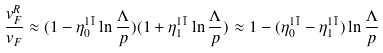<formula> <loc_0><loc_0><loc_500><loc_500>\frac { v _ { F } ^ { R } } { v _ { F } } \approx ( 1 - \eta ^ { 1 \bar { 1 } } _ { 0 } \ln { \frac { \Lambda } { p } } ) ( 1 + \eta ^ { 1 \bar { 1 } } _ { 1 } \ln { \frac { \Lambda } { p } } ) \approx 1 - ( \eta ^ { 1 \bar { 1 } } _ { 0 } - \eta ^ { 1 \bar { 1 } } _ { 1 } ) \ln { \frac { \Lambda } { p } }</formula> 